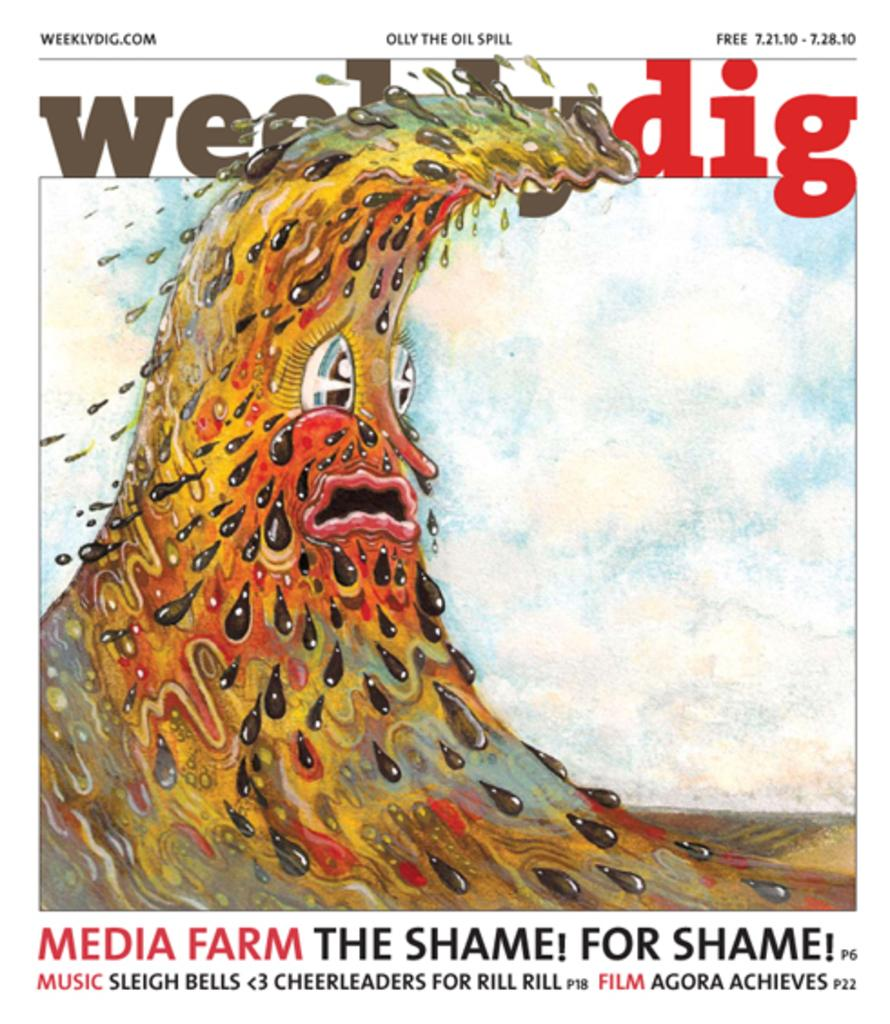<image>
Share a concise interpretation of the image provided. cover of the weeklydig magazine for 7.12.10 showing an illustration of  an anthropomorphic sludge wave 